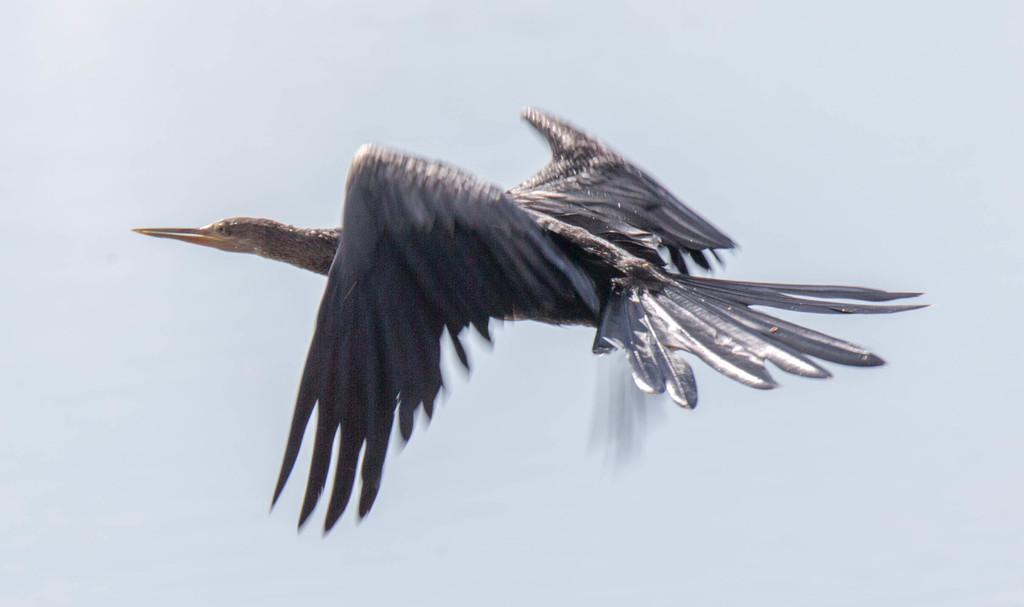What is happening in the image? There is a bird flying in the image. Where is the bird located in the image? The bird is in the center of the image. What type of pot is the bird using to trip over in the image? There is no pot or tripping incident involving the bird in the image. 